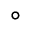Convert formula to latex. <formula><loc_0><loc_0><loc_500><loc_500>^ { \circ }</formula> 